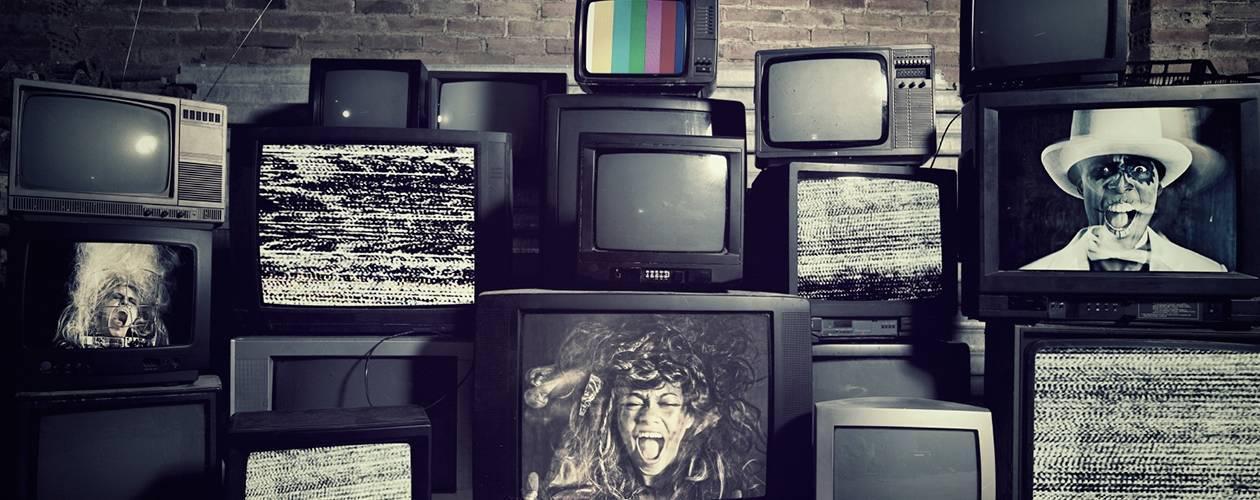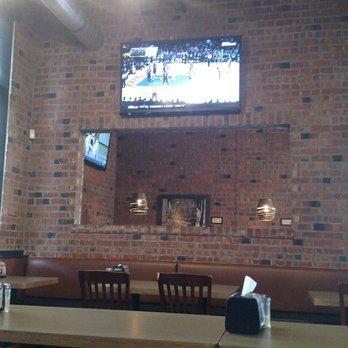The first image is the image on the left, the second image is the image on the right. Considering the images on both sides, is "Each image shows a single flat screen TV, and at least one image features an aerial city view on the screen." valid? Answer yes or no. No. The first image is the image on the left, the second image is the image on the right. For the images shown, is this caption "Each image is of a single high definition flat screen television set to a standard advertisement screen, with its stand visible below the television." true? Answer yes or no. No. 